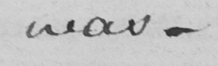What does this handwritten line say? was- 